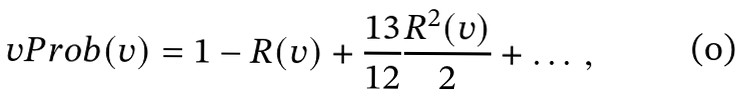Convert formula to latex. <formula><loc_0><loc_0><loc_500><loc_500>\ v P r o b ( v ) = 1 - R ( v ) + \frac { 1 3 } { 1 2 } \frac { R ^ { 2 } ( v ) } { 2 } + \dots \, ,</formula> 